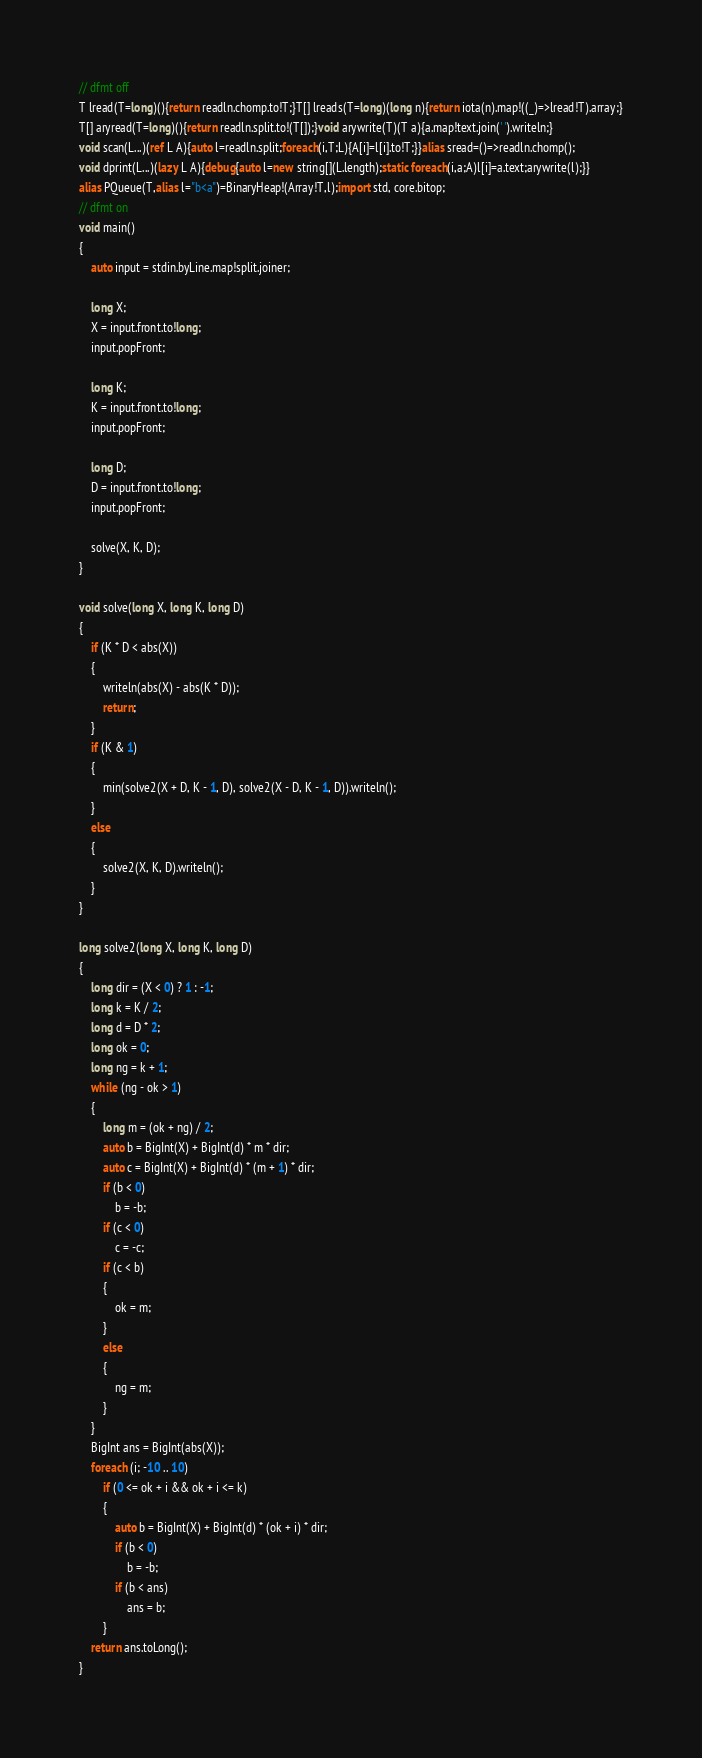<code> <loc_0><loc_0><loc_500><loc_500><_D_>// dfmt off
T lread(T=long)(){return readln.chomp.to!T;}T[] lreads(T=long)(long n){return iota(n).map!((_)=>lread!T).array;}
T[] aryread(T=long)(){return readln.split.to!(T[]);}void arywrite(T)(T a){a.map!text.join(' ').writeln;}
void scan(L...)(ref L A){auto l=readln.split;foreach(i,T;L){A[i]=l[i].to!T;}}alias sread=()=>readln.chomp();
void dprint(L...)(lazy L A){debug{auto l=new string[](L.length);static foreach(i,a;A)l[i]=a.text;arywrite(l);}}
alias PQueue(T,alias l="b<a")=BinaryHeap!(Array!T,l);import std, core.bitop;
// dfmt on
void main()
{
    auto input = stdin.byLine.map!split.joiner;

    long X;
    X = input.front.to!long;
    input.popFront;

    long K;
    K = input.front.to!long;
    input.popFront;

    long D;
    D = input.front.to!long;
    input.popFront;

    solve(X, K, D);
}

void solve(long X, long K, long D)
{
    if (K * D < abs(X))
    {
        writeln(abs(X) - abs(K * D));
        return;
    }
    if (K & 1)
    {
        min(solve2(X + D, K - 1, D), solve2(X - D, K - 1, D)).writeln();
    }
    else
    {
        solve2(X, K, D).writeln();
    }
}

long solve2(long X, long K, long D)
{
    long dir = (X < 0) ? 1 : -1;
    long k = K / 2;
    long d = D * 2;
    long ok = 0;
    long ng = k + 1;
    while (ng - ok > 1)
    {
        long m = (ok + ng) / 2;
        auto b = BigInt(X) + BigInt(d) * m * dir;
        auto c = BigInt(X) + BigInt(d) * (m + 1) * dir;
        if (b < 0)
            b = -b;
        if (c < 0)
            c = -c;
        if (c < b)
        {
            ok = m;
        }
        else
        {
            ng = m;
        }
    }
    BigInt ans = BigInt(abs(X));
    foreach (i; -10 .. 10)
        if (0 <= ok + i && ok + i <= k)
        {
            auto b = BigInt(X) + BigInt(d) * (ok + i) * dir;
            if (b < 0)
                b = -b;
            if (b < ans)
                ans = b;
        }
    return ans.toLong();
}
</code> 